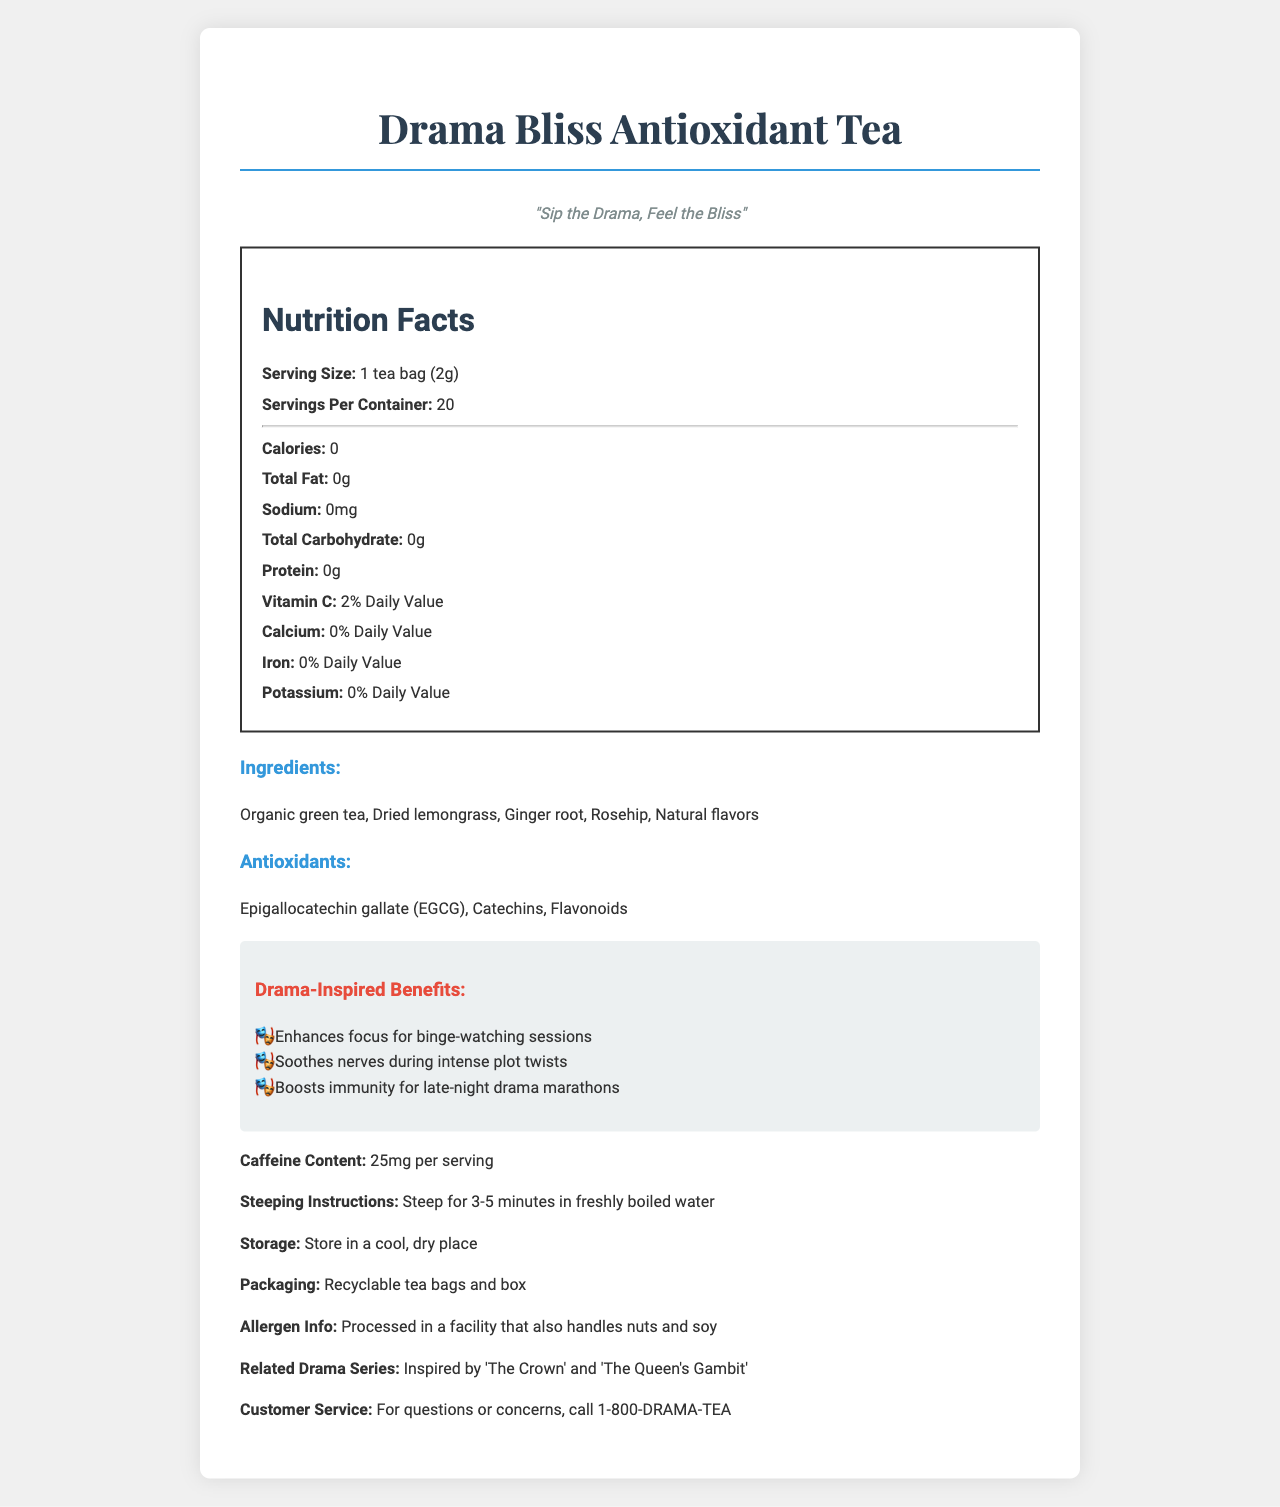what is the product name? The product name is clearly stated at the top of the document.
Answer: Drama Bliss Antioxidant Tea what is the serving size? The serving size is listed under the Nutrition Facts section.
Answer: 1 tea bag (2g) how many servings are in each container? The document specifies that there are 20 servings per container.
Answer: 20 how much caffeine is in each serving? The caffeine content per serving is listed near the end of the document.
Answer: 25mg what are the three main antioxidants found in this tea? The antioxidants are listed in a specific section under the ingredients.
Answer: Epigallocatechin gallate (EGCG), Catechins, Flavonoids how long should the tea be steeped? The steeping instructions specify to steep the tea for 3-5 minutes in freshly boiled water.
Answer: 3-5 minutes what is the tagline for this product? The tagline is found in the introductory section beneath the product name.
Answer: Sip the Drama, Feel the Bliss what is the flavor of this tea? The flavor is specified next to the product name near the top of the document.
Answer: Crown's Gambit Green Tea what are the drama-inspired benefits listed? (Select all that apply)
A. Enhances focus for binge-watching sessions
B. Tones muscles for intense action
C. Boosts immunity for late-night drama marathons 
D. Provides energy for early-morning meetings The drama-inspired benefits listed are "Enhances focus for binge-watching sessions" and "Boosts immunity for late-night drama marathons."
Answer: A, C which ingredient is not organic in the tea blend? A. Organic green tea B. Dried lemongrass C. Ginger root D. Natural flavors Natural flavors is the ingredient not labeled as organic.
Answer: D does this tea contain any calories? The Nutrition Facts label shows that the tea has 0 calories.
Answer: No is the packaging recyclable? The document states that the packaging is recyclable.
Answer: Yes what are the health benefits mentioned for this tea? The health benefits are tied to the drama-inspired benefits listed in the Drama-Inspired Benefits section.
Answer: Enhances focus, Soothes nerves, Boosts immunity does the tea contain any nut allergens? The allergen info section specifies that the tea is processed in a facility that also handles nuts and soy, implying a potential contamination risk.
Answer: Processed in a facility that also handles nuts and soy summarize the main idea of the document. The summary includes the product title, health and nutritional benefits, associated drama series, and practical details such as usage instructions and ingredient list.
Answer: The document details the Nutrition Facts for Drama Bliss Antioxidant Tea, specifically the Crown's Gambit Green Tea flavor. It highlights its zero-calorie content, antioxidant ingredients, drama-inspired health benefits, caffeine content, instructions for use, and packaging information, with a clear theme tying back to popular drama series. who is the target customer service contact? The customer service contact is provided at the end of the document.
Answer: 1-800-DRAMA-TEA what is the percentage of daily value of Vitamin C in the tea? The Vitamin C content is listed as 2% of the daily value.
Answer: 2% Daily Value who is the manufacturer of this product? The document does not provide information about the manufacturer of the product.
Answer: Not enough information 